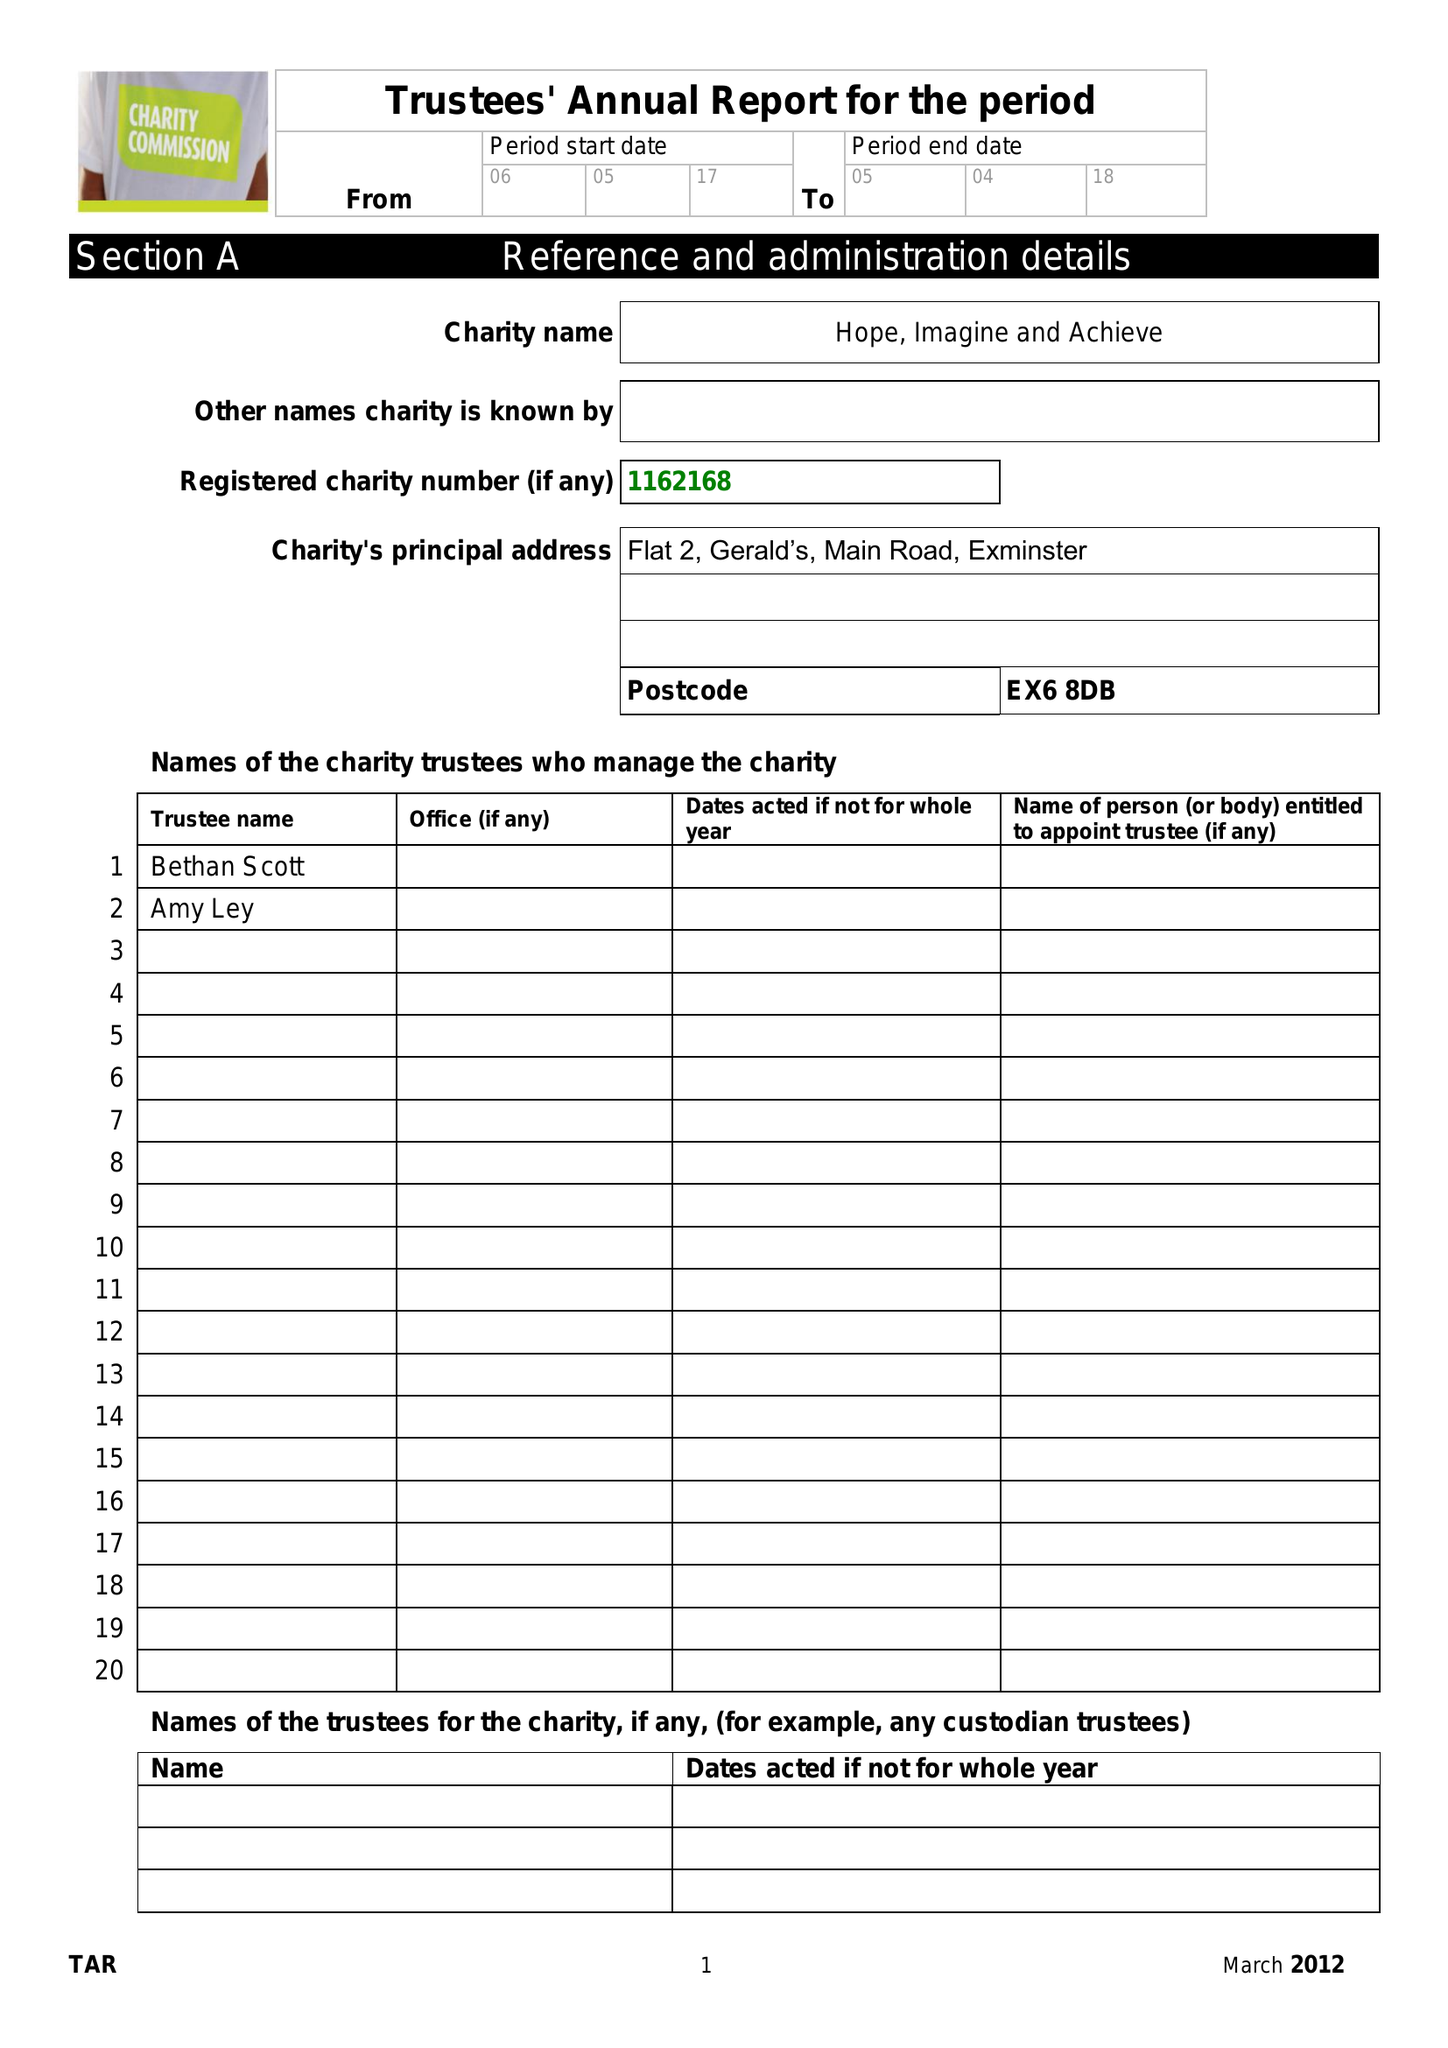What is the value for the report_date?
Answer the question using a single word or phrase. 2018-04-05 